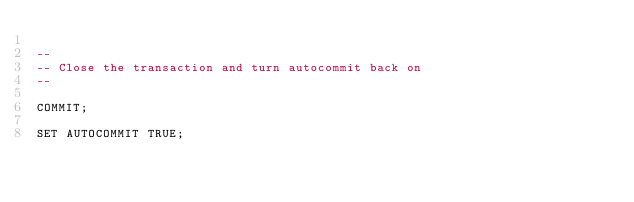<code> <loc_0><loc_0><loc_500><loc_500><_SQL_>   
-- 
-- Close the transaction and turn autocommit back on
-- 
    
COMMIT;

SET AUTOCOMMIT TRUE;

</code> 